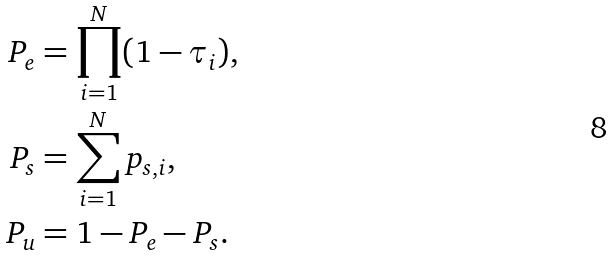<formula> <loc_0><loc_0><loc_500><loc_500>P _ { e } & = \prod _ { i = 1 } ^ { N } ( 1 - \tau _ { i } ) , \\ P _ { s } & = \sum _ { i = 1 } ^ { N } p _ { s , i } , \\ P _ { u } & = 1 - P _ { e } - P _ { s } .</formula> 